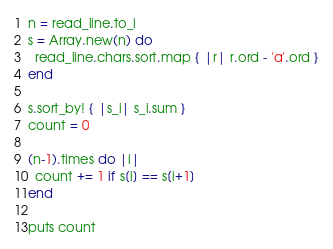<code> <loc_0><loc_0><loc_500><loc_500><_Crystal_>n = read_line.to_i
s = Array.new(n) do
  read_line.chars.sort.map { |r| r.ord - 'a'.ord }
end

s.sort_by! { |s_i| s_i.sum }
count = 0

(n-1).times do |i|
  count += 1 if s[i] == s[i+1]
end

puts count</code> 